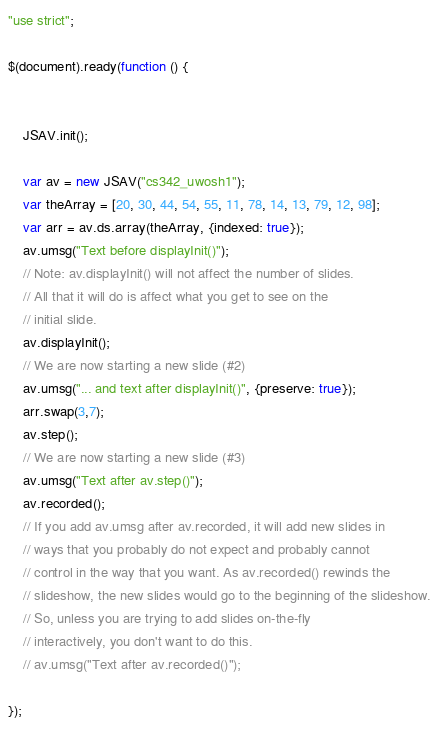<code> <loc_0><loc_0><loc_500><loc_500><_JavaScript_>"use strict";

$(document).ready(function () {


    JSAV.init();

    var av = new JSAV("cs342_uwosh1");
    var theArray = [20, 30, 44, 54, 55, 11, 78, 14, 13, 79, 12, 98];
    var arr = av.ds.array(theArray, {indexed: true});
    av.umsg("Text before displayInit()");
    // Note: av.displayInit() will not affect the number of slides.
    // All that it will do is affect what you get to see on the
    // initial slide.
    av.displayInit();
    // We are now starting a new slide (#2)
    av.umsg("... and text after displayInit()", {preserve: true});
    arr.swap(3,7);
    av.step();
    // We are now starting a new slide (#3)
    av.umsg("Text after av.step()");
    av.recorded();
    // If you add av.umsg after av.recorded, it will add new slides in
    // ways that you probably do not expect and probably cannot
    // control in the way that you want. As av.recorded() rewinds the
    // slideshow, the new slides would go to the beginning of the slideshow.
    // So, unless you are trying to add slides on-the-fly
    // interactively, you don't want to do this.
    // av.umsg("Text after av.recorded()");

});
</code> 